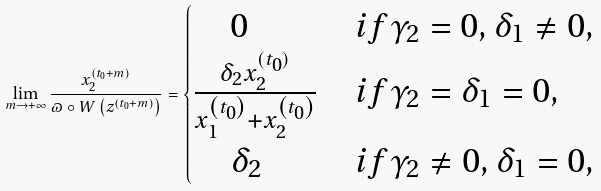<formula> <loc_0><loc_0><loc_500><loc_500>\lim _ { m \rightarrow + \infty } \frac { x _ { 2 } ^ { \left ( t _ { 0 } + m \right ) } } { \varpi \circ W \left ( z ^ { \left ( t _ { 0 } + m \right ) } \right ) } = \begin{cases} \quad 0 & i f \gamma _ { 2 } = 0 , \delta _ { 1 } \neq 0 , \\ \frac { \delta _ { 2 } x _ { 2 } ^ { ( t _ { 0 } ) } } { x _ { 1 } ^ { \left ( t _ { 0 } \right ) } + x _ { 2 } ^ { \left ( t _ { 0 } \right ) } } & i f \gamma _ { 2 } = \delta _ { 1 } = 0 , \\ \quad \delta _ { 2 } & i f \gamma _ { 2 } \neq 0 , \delta _ { 1 } = 0 , \end{cases}</formula> 